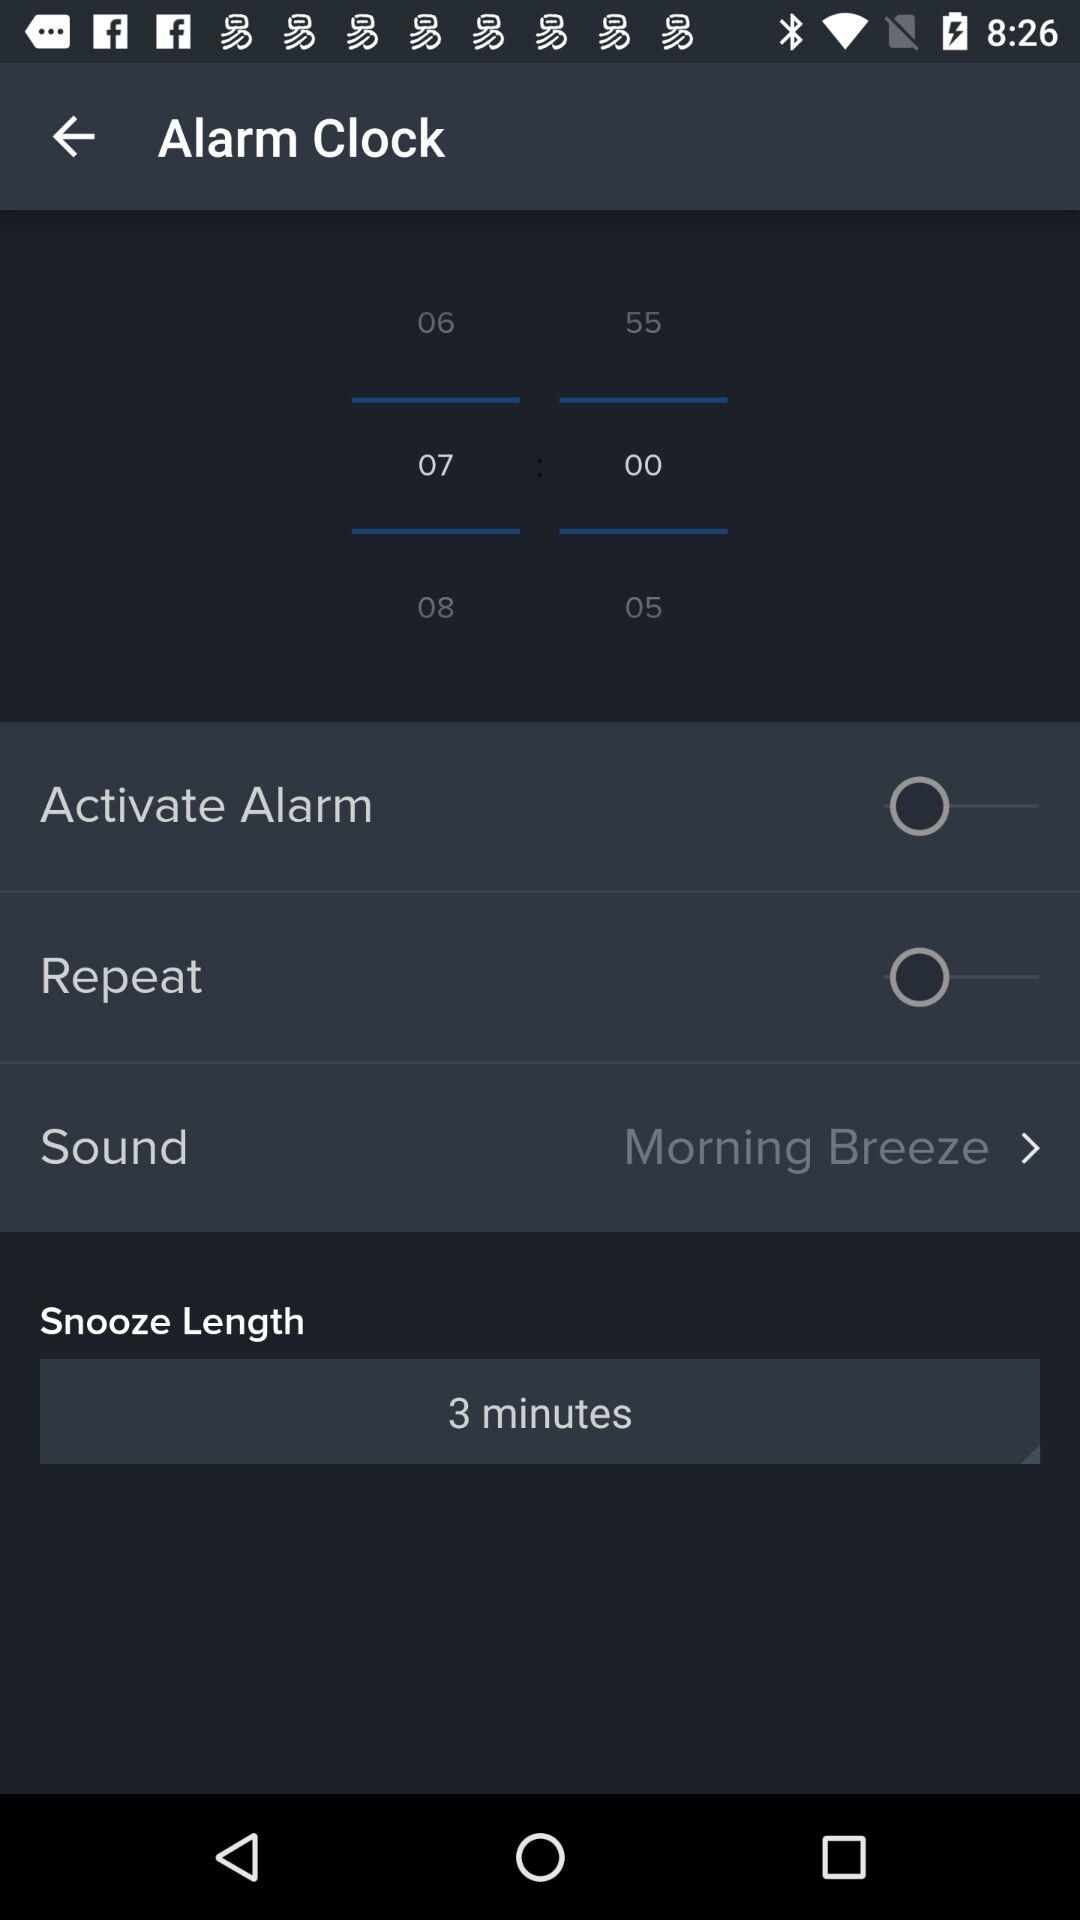What is the selected alarm time? The selected alarm time is 07:00. 